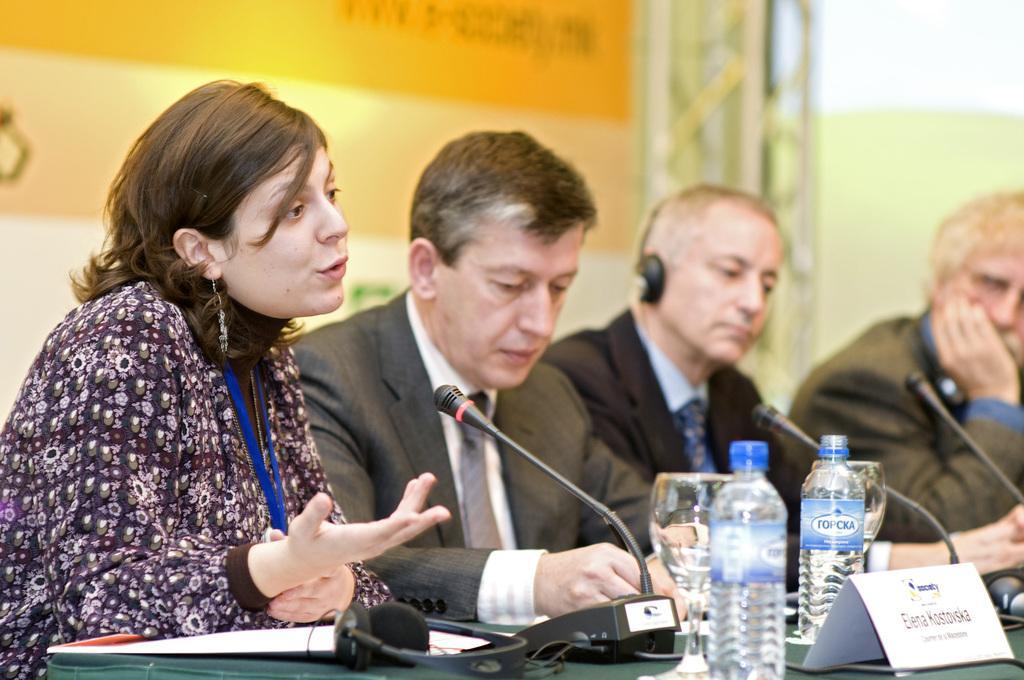How would you summarize this image in a sentence or two? Here we can see four persons are sitting on the chairs and she is talking on the mike. This is a table. On the table there are bottles, glasses, mike's, headset, and a paper. In the background we can see a banner and it is blurry. 